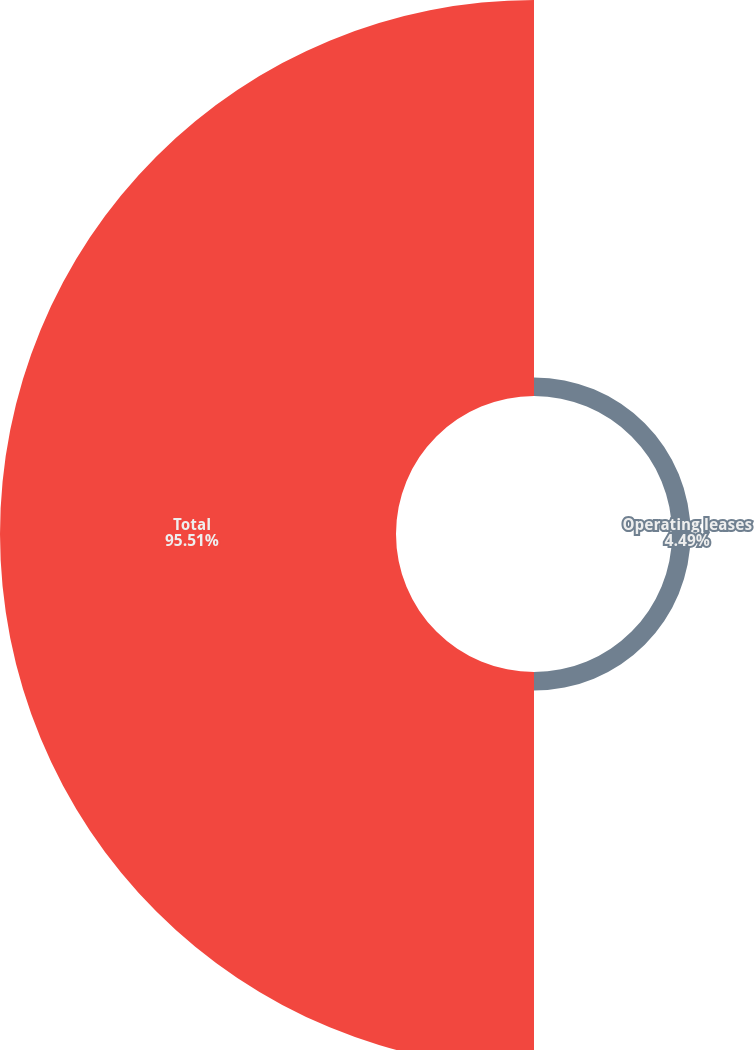Convert chart. <chart><loc_0><loc_0><loc_500><loc_500><pie_chart><fcel>Operating leases<fcel>Total<nl><fcel>4.49%<fcel>95.51%<nl></chart> 